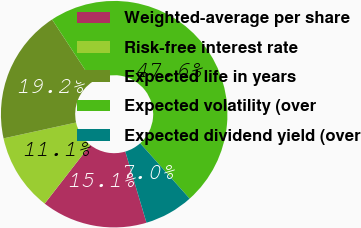Convert chart to OTSL. <chart><loc_0><loc_0><loc_500><loc_500><pie_chart><fcel>Weighted-average per share<fcel>Risk-free interest rate<fcel>Expected life in years<fcel>Expected volatility (over<fcel>Expected dividend yield (over<nl><fcel>15.12%<fcel>11.06%<fcel>19.19%<fcel>47.63%<fcel>7.0%<nl></chart> 